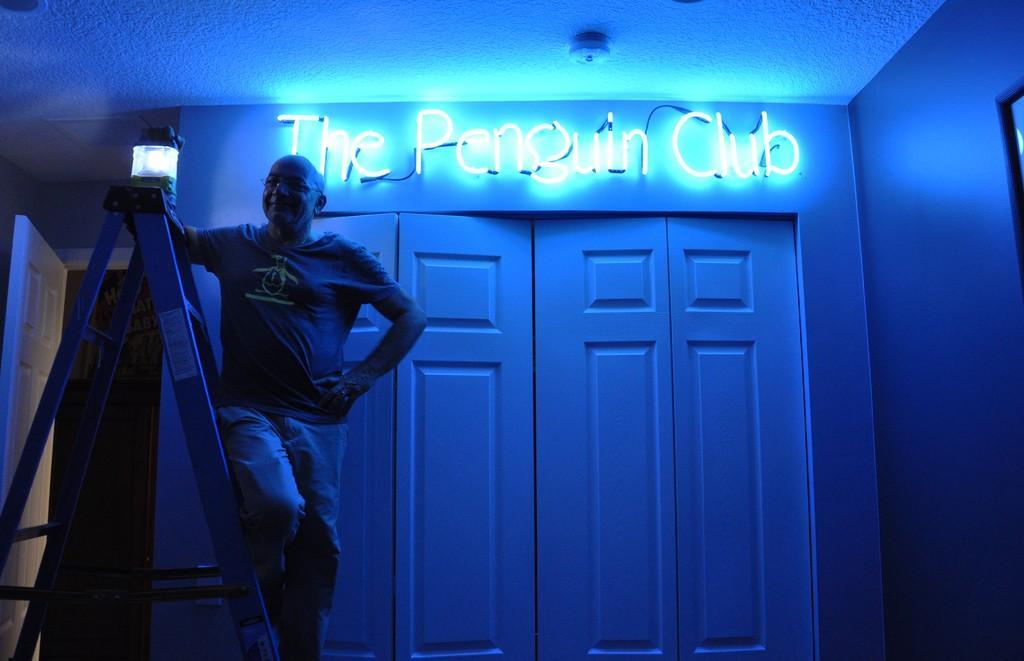Could you give a brief overview of what you see in this image? This is the picture of a room. In this image there is a man standing on the ladder and he is smiling and there is a light on the ladder. At the back there is a door. In the middle of the image there is text on the wall and there is a door. On the right side of the image it looks like a frame on the wall. 